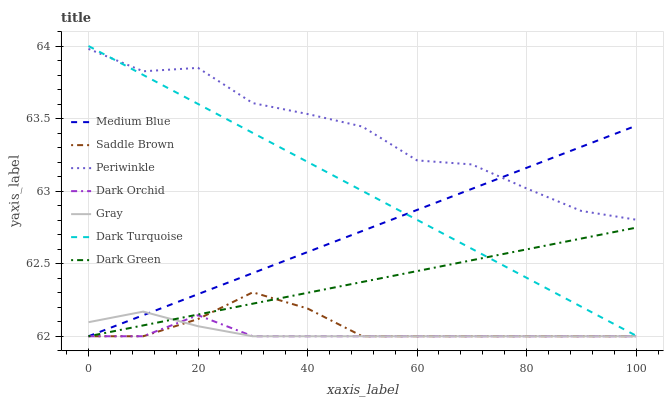Does Dark Orchid have the minimum area under the curve?
Answer yes or no. Yes. Does Periwinkle have the maximum area under the curve?
Answer yes or no. Yes. Does Dark Turquoise have the minimum area under the curve?
Answer yes or no. No. Does Dark Turquoise have the maximum area under the curve?
Answer yes or no. No. Is Dark Green the smoothest?
Answer yes or no. Yes. Is Periwinkle the roughest?
Answer yes or no. Yes. Is Dark Turquoise the smoothest?
Answer yes or no. No. Is Dark Turquoise the roughest?
Answer yes or no. No. Does Gray have the lowest value?
Answer yes or no. Yes. Does Dark Turquoise have the lowest value?
Answer yes or no. No. Does Dark Turquoise have the highest value?
Answer yes or no. Yes. Does Medium Blue have the highest value?
Answer yes or no. No. Is Gray less than Dark Turquoise?
Answer yes or no. Yes. Is Dark Turquoise greater than Saddle Brown?
Answer yes or no. Yes. Does Saddle Brown intersect Gray?
Answer yes or no. Yes. Is Saddle Brown less than Gray?
Answer yes or no. No. Is Saddle Brown greater than Gray?
Answer yes or no. No. Does Gray intersect Dark Turquoise?
Answer yes or no. No. 